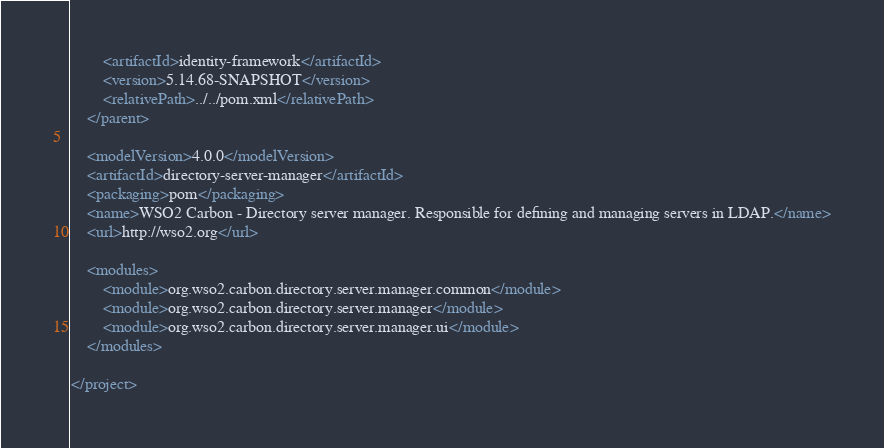Convert code to text. <code><loc_0><loc_0><loc_500><loc_500><_XML_>        <artifactId>identity-framework</artifactId>
        <version>5.14.68-SNAPSHOT</version>
        <relativePath>../../pom.xml</relativePath>
    </parent>

    <modelVersion>4.0.0</modelVersion>
    <artifactId>directory-server-manager</artifactId>
    <packaging>pom</packaging>
    <name>WSO2 Carbon - Directory server manager. Responsible for defining and managing servers in LDAP.</name>
    <url>http://wso2.org</url>

    <modules>
        <module>org.wso2.carbon.directory.server.manager.common</module>
        <module>org.wso2.carbon.directory.server.manager</module>
        <module>org.wso2.carbon.directory.server.manager.ui</module>
    </modules>

</project>
</code> 